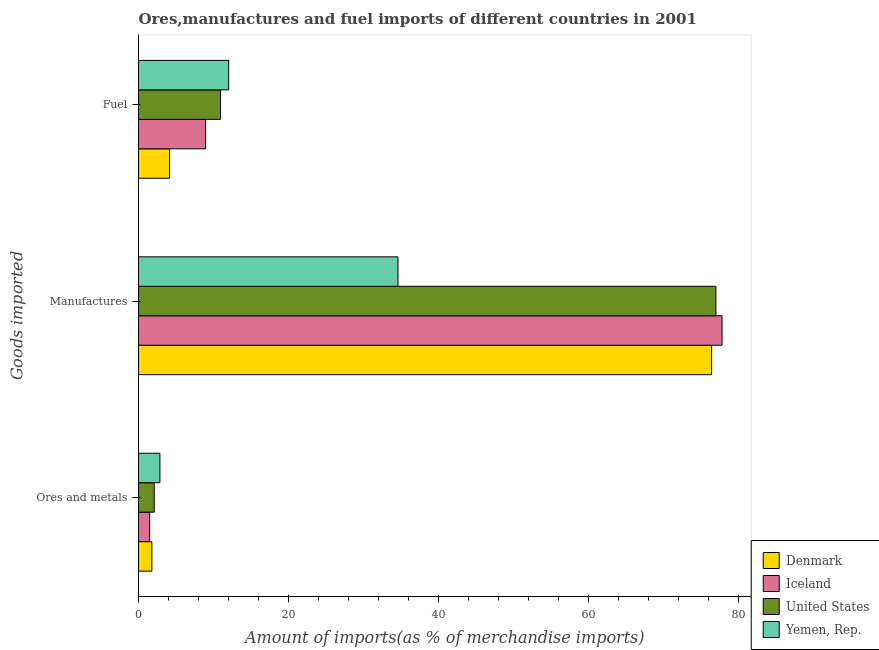How many different coloured bars are there?
Give a very brief answer. 4. How many groups of bars are there?
Your answer should be compact. 3. Are the number of bars per tick equal to the number of legend labels?
Your response must be concise. Yes. Are the number of bars on each tick of the Y-axis equal?
Make the answer very short. Yes. How many bars are there on the 2nd tick from the top?
Offer a terse response. 4. What is the label of the 2nd group of bars from the top?
Offer a terse response. Manufactures. What is the percentage of fuel imports in Denmark?
Your answer should be compact. 4.15. Across all countries, what is the maximum percentage of fuel imports?
Provide a succinct answer. 12.02. Across all countries, what is the minimum percentage of manufactures imports?
Provide a short and direct response. 34.57. In which country was the percentage of manufactures imports maximum?
Ensure brevity in your answer.  Iceland. In which country was the percentage of manufactures imports minimum?
Give a very brief answer. Yemen, Rep. What is the total percentage of ores and metals imports in the graph?
Offer a terse response. 8.21. What is the difference between the percentage of fuel imports in United States and that in Denmark?
Give a very brief answer. 6.79. What is the difference between the percentage of ores and metals imports in Denmark and the percentage of manufactures imports in Iceland?
Offer a terse response. -75.98. What is the average percentage of fuel imports per country?
Your answer should be compact. 9.01. What is the difference between the percentage of ores and metals imports and percentage of manufactures imports in United States?
Give a very brief answer. -74.85. In how many countries, is the percentage of manufactures imports greater than 28 %?
Provide a short and direct response. 4. What is the ratio of the percentage of fuel imports in Yemen, Rep. to that in United States?
Your response must be concise. 1.1. Is the percentage of fuel imports in Iceland less than that in United States?
Make the answer very short. Yes. Is the difference between the percentage of ores and metals imports in Denmark and Iceland greater than the difference between the percentage of fuel imports in Denmark and Iceland?
Your answer should be very brief. Yes. What is the difference between the highest and the second highest percentage of fuel imports?
Make the answer very short. 1.08. What is the difference between the highest and the lowest percentage of manufactures imports?
Give a very brief answer. 43.19. What does the 1st bar from the top in Ores and metals represents?
Your answer should be compact. Yemen, Rep. What does the 2nd bar from the bottom in Fuel represents?
Your response must be concise. Iceland. Are all the bars in the graph horizontal?
Give a very brief answer. Yes. How many countries are there in the graph?
Your answer should be compact. 4. What is the difference between two consecutive major ticks on the X-axis?
Provide a succinct answer. 20. Does the graph contain any zero values?
Provide a short and direct response. No. Does the graph contain grids?
Ensure brevity in your answer.  No. Where does the legend appear in the graph?
Offer a very short reply. Bottom right. How many legend labels are there?
Provide a succinct answer. 4. How are the legend labels stacked?
Ensure brevity in your answer.  Vertical. What is the title of the graph?
Your answer should be very brief. Ores,manufactures and fuel imports of different countries in 2001. What is the label or title of the X-axis?
Ensure brevity in your answer.  Amount of imports(as % of merchandise imports). What is the label or title of the Y-axis?
Your response must be concise. Goods imported. What is the Amount of imports(as % of merchandise imports) of Denmark in Ores and metals?
Make the answer very short. 1.78. What is the Amount of imports(as % of merchandise imports) in Iceland in Ores and metals?
Offer a very short reply. 1.49. What is the Amount of imports(as % of merchandise imports) of United States in Ores and metals?
Provide a succinct answer. 2.09. What is the Amount of imports(as % of merchandise imports) in Yemen, Rep. in Ores and metals?
Your response must be concise. 2.85. What is the Amount of imports(as % of merchandise imports) in Denmark in Manufactures?
Your answer should be compact. 76.38. What is the Amount of imports(as % of merchandise imports) of Iceland in Manufactures?
Your answer should be compact. 77.76. What is the Amount of imports(as % of merchandise imports) in United States in Manufactures?
Your answer should be very brief. 76.95. What is the Amount of imports(as % of merchandise imports) in Yemen, Rep. in Manufactures?
Provide a short and direct response. 34.57. What is the Amount of imports(as % of merchandise imports) of Denmark in Fuel?
Keep it short and to the point. 4.15. What is the Amount of imports(as % of merchandise imports) in Iceland in Fuel?
Give a very brief answer. 8.94. What is the Amount of imports(as % of merchandise imports) in United States in Fuel?
Make the answer very short. 10.94. What is the Amount of imports(as % of merchandise imports) of Yemen, Rep. in Fuel?
Provide a short and direct response. 12.02. Across all Goods imported, what is the maximum Amount of imports(as % of merchandise imports) in Denmark?
Offer a terse response. 76.38. Across all Goods imported, what is the maximum Amount of imports(as % of merchandise imports) in Iceland?
Make the answer very short. 77.76. Across all Goods imported, what is the maximum Amount of imports(as % of merchandise imports) of United States?
Your answer should be compact. 76.95. Across all Goods imported, what is the maximum Amount of imports(as % of merchandise imports) of Yemen, Rep.?
Your response must be concise. 34.57. Across all Goods imported, what is the minimum Amount of imports(as % of merchandise imports) in Denmark?
Offer a terse response. 1.78. Across all Goods imported, what is the minimum Amount of imports(as % of merchandise imports) in Iceland?
Keep it short and to the point. 1.49. Across all Goods imported, what is the minimum Amount of imports(as % of merchandise imports) in United States?
Your response must be concise. 2.09. Across all Goods imported, what is the minimum Amount of imports(as % of merchandise imports) of Yemen, Rep.?
Keep it short and to the point. 2.85. What is the total Amount of imports(as % of merchandise imports) in Denmark in the graph?
Make the answer very short. 82.3. What is the total Amount of imports(as % of merchandise imports) in Iceland in the graph?
Your answer should be very brief. 88.19. What is the total Amount of imports(as % of merchandise imports) of United States in the graph?
Your response must be concise. 89.98. What is the total Amount of imports(as % of merchandise imports) of Yemen, Rep. in the graph?
Keep it short and to the point. 49.44. What is the difference between the Amount of imports(as % of merchandise imports) in Denmark in Ores and metals and that in Manufactures?
Provide a succinct answer. -74.59. What is the difference between the Amount of imports(as % of merchandise imports) of Iceland in Ores and metals and that in Manufactures?
Offer a very short reply. -76.28. What is the difference between the Amount of imports(as % of merchandise imports) in United States in Ores and metals and that in Manufactures?
Offer a terse response. -74.85. What is the difference between the Amount of imports(as % of merchandise imports) of Yemen, Rep. in Ores and metals and that in Manufactures?
Ensure brevity in your answer.  -31.72. What is the difference between the Amount of imports(as % of merchandise imports) in Denmark in Ores and metals and that in Fuel?
Provide a succinct answer. -2.36. What is the difference between the Amount of imports(as % of merchandise imports) of Iceland in Ores and metals and that in Fuel?
Provide a succinct answer. -7.46. What is the difference between the Amount of imports(as % of merchandise imports) of United States in Ores and metals and that in Fuel?
Your answer should be very brief. -8.84. What is the difference between the Amount of imports(as % of merchandise imports) of Yemen, Rep. in Ores and metals and that in Fuel?
Your answer should be very brief. -9.17. What is the difference between the Amount of imports(as % of merchandise imports) of Denmark in Manufactures and that in Fuel?
Offer a terse response. 72.23. What is the difference between the Amount of imports(as % of merchandise imports) in Iceland in Manufactures and that in Fuel?
Your answer should be compact. 68.82. What is the difference between the Amount of imports(as % of merchandise imports) in United States in Manufactures and that in Fuel?
Make the answer very short. 66.01. What is the difference between the Amount of imports(as % of merchandise imports) of Yemen, Rep. in Manufactures and that in Fuel?
Your answer should be compact. 22.55. What is the difference between the Amount of imports(as % of merchandise imports) of Denmark in Ores and metals and the Amount of imports(as % of merchandise imports) of Iceland in Manufactures?
Provide a short and direct response. -75.98. What is the difference between the Amount of imports(as % of merchandise imports) in Denmark in Ores and metals and the Amount of imports(as % of merchandise imports) in United States in Manufactures?
Ensure brevity in your answer.  -75.17. What is the difference between the Amount of imports(as % of merchandise imports) of Denmark in Ores and metals and the Amount of imports(as % of merchandise imports) of Yemen, Rep. in Manufactures?
Your answer should be very brief. -32.79. What is the difference between the Amount of imports(as % of merchandise imports) in Iceland in Ores and metals and the Amount of imports(as % of merchandise imports) in United States in Manufactures?
Your answer should be very brief. -75.46. What is the difference between the Amount of imports(as % of merchandise imports) of Iceland in Ores and metals and the Amount of imports(as % of merchandise imports) of Yemen, Rep. in Manufactures?
Keep it short and to the point. -33.09. What is the difference between the Amount of imports(as % of merchandise imports) of United States in Ores and metals and the Amount of imports(as % of merchandise imports) of Yemen, Rep. in Manufactures?
Your answer should be very brief. -32.48. What is the difference between the Amount of imports(as % of merchandise imports) in Denmark in Ores and metals and the Amount of imports(as % of merchandise imports) in Iceland in Fuel?
Your response must be concise. -7.16. What is the difference between the Amount of imports(as % of merchandise imports) in Denmark in Ores and metals and the Amount of imports(as % of merchandise imports) in United States in Fuel?
Your answer should be compact. -9.16. What is the difference between the Amount of imports(as % of merchandise imports) of Denmark in Ores and metals and the Amount of imports(as % of merchandise imports) of Yemen, Rep. in Fuel?
Offer a very short reply. -10.24. What is the difference between the Amount of imports(as % of merchandise imports) of Iceland in Ores and metals and the Amount of imports(as % of merchandise imports) of United States in Fuel?
Offer a terse response. -9.45. What is the difference between the Amount of imports(as % of merchandise imports) of Iceland in Ores and metals and the Amount of imports(as % of merchandise imports) of Yemen, Rep. in Fuel?
Give a very brief answer. -10.53. What is the difference between the Amount of imports(as % of merchandise imports) in United States in Ores and metals and the Amount of imports(as % of merchandise imports) in Yemen, Rep. in Fuel?
Your answer should be compact. -9.93. What is the difference between the Amount of imports(as % of merchandise imports) in Denmark in Manufactures and the Amount of imports(as % of merchandise imports) in Iceland in Fuel?
Your answer should be compact. 67.43. What is the difference between the Amount of imports(as % of merchandise imports) in Denmark in Manufactures and the Amount of imports(as % of merchandise imports) in United States in Fuel?
Offer a very short reply. 65.44. What is the difference between the Amount of imports(as % of merchandise imports) of Denmark in Manufactures and the Amount of imports(as % of merchandise imports) of Yemen, Rep. in Fuel?
Your response must be concise. 64.36. What is the difference between the Amount of imports(as % of merchandise imports) in Iceland in Manufactures and the Amount of imports(as % of merchandise imports) in United States in Fuel?
Offer a terse response. 66.83. What is the difference between the Amount of imports(as % of merchandise imports) in Iceland in Manufactures and the Amount of imports(as % of merchandise imports) in Yemen, Rep. in Fuel?
Keep it short and to the point. 65.74. What is the difference between the Amount of imports(as % of merchandise imports) of United States in Manufactures and the Amount of imports(as % of merchandise imports) of Yemen, Rep. in Fuel?
Give a very brief answer. 64.93. What is the average Amount of imports(as % of merchandise imports) of Denmark per Goods imported?
Give a very brief answer. 27.43. What is the average Amount of imports(as % of merchandise imports) in Iceland per Goods imported?
Keep it short and to the point. 29.4. What is the average Amount of imports(as % of merchandise imports) of United States per Goods imported?
Offer a very short reply. 29.99. What is the average Amount of imports(as % of merchandise imports) in Yemen, Rep. per Goods imported?
Give a very brief answer. 16.48. What is the difference between the Amount of imports(as % of merchandise imports) in Denmark and Amount of imports(as % of merchandise imports) in Iceland in Ores and metals?
Your answer should be compact. 0.29. What is the difference between the Amount of imports(as % of merchandise imports) in Denmark and Amount of imports(as % of merchandise imports) in United States in Ores and metals?
Ensure brevity in your answer.  -0.31. What is the difference between the Amount of imports(as % of merchandise imports) of Denmark and Amount of imports(as % of merchandise imports) of Yemen, Rep. in Ores and metals?
Keep it short and to the point. -1.07. What is the difference between the Amount of imports(as % of merchandise imports) in Iceland and Amount of imports(as % of merchandise imports) in United States in Ores and metals?
Ensure brevity in your answer.  -0.61. What is the difference between the Amount of imports(as % of merchandise imports) in Iceland and Amount of imports(as % of merchandise imports) in Yemen, Rep. in Ores and metals?
Offer a very short reply. -1.37. What is the difference between the Amount of imports(as % of merchandise imports) of United States and Amount of imports(as % of merchandise imports) of Yemen, Rep. in Ores and metals?
Your answer should be very brief. -0.76. What is the difference between the Amount of imports(as % of merchandise imports) in Denmark and Amount of imports(as % of merchandise imports) in Iceland in Manufactures?
Give a very brief answer. -1.39. What is the difference between the Amount of imports(as % of merchandise imports) in Denmark and Amount of imports(as % of merchandise imports) in United States in Manufactures?
Offer a very short reply. -0.57. What is the difference between the Amount of imports(as % of merchandise imports) in Denmark and Amount of imports(as % of merchandise imports) in Yemen, Rep. in Manufactures?
Your response must be concise. 41.8. What is the difference between the Amount of imports(as % of merchandise imports) in Iceland and Amount of imports(as % of merchandise imports) in United States in Manufactures?
Keep it short and to the point. 0.82. What is the difference between the Amount of imports(as % of merchandise imports) of Iceland and Amount of imports(as % of merchandise imports) of Yemen, Rep. in Manufactures?
Offer a very short reply. 43.19. What is the difference between the Amount of imports(as % of merchandise imports) in United States and Amount of imports(as % of merchandise imports) in Yemen, Rep. in Manufactures?
Make the answer very short. 42.38. What is the difference between the Amount of imports(as % of merchandise imports) in Denmark and Amount of imports(as % of merchandise imports) in Iceland in Fuel?
Your response must be concise. -4.8. What is the difference between the Amount of imports(as % of merchandise imports) in Denmark and Amount of imports(as % of merchandise imports) in United States in Fuel?
Ensure brevity in your answer.  -6.79. What is the difference between the Amount of imports(as % of merchandise imports) in Denmark and Amount of imports(as % of merchandise imports) in Yemen, Rep. in Fuel?
Provide a succinct answer. -7.87. What is the difference between the Amount of imports(as % of merchandise imports) in Iceland and Amount of imports(as % of merchandise imports) in United States in Fuel?
Your answer should be compact. -1.99. What is the difference between the Amount of imports(as % of merchandise imports) in Iceland and Amount of imports(as % of merchandise imports) in Yemen, Rep. in Fuel?
Your response must be concise. -3.08. What is the difference between the Amount of imports(as % of merchandise imports) in United States and Amount of imports(as % of merchandise imports) in Yemen, Rep. in Fuel?
Your answer should be compact. -1.08. What is the ratio of the Amount of imports(as % of merchandise imports) of Denmark in Ores and metals to that in Manufactures?
Make the answer very short. 0.02. What is the ratio of the Amount of imports(as % of merchandise imports) of Iceland in Ores and metals to that in Manufactures?
Make the answer very short. 0.02. What is the ratio of the Amount of imports(as % of merchandise imports) in United States in Ores and metals to that in Manufactures?
Make the answer very short. 0.03. What is the ratio of the Amount of imports(as % of merchandise imports) of Yemen, Rep. in Ores and metals to that in Manufactures?
Make the answer very short. 0.08. What is the ratio of the Amount of imports(as % of merchandise imports) of Denmark in Ores and metals to that in Fuel?
Your response must be concise. 0.43. What is the ratio of the Amount of imports(as % of merchandise imports) in Iceland in Ores and metals to that in Fuel?
Give a very brief answer. 0.17. What is the ratio of the Amount of imports(as % of merchandise imports) in United States in Ores and metals to that in Fuel?
Your response must be concise. 0.19. What is the ratio of the Amount of imports(as % of merchandise imports) in Yemen, Rep. in Ores and metals to that in Fuel?
Offer a very short reply. 0.24. What is the ratio of the Amount of imports(as % of merchandise imports) of Denmark in Manufactures to that in Fuel?
Keep it short and to the point. 18.43. What is the ratio of the Amount of imports(as % of merchandise imports) in Iceland in Manufactures to that in Fuel?
Your answer should be very brief. 8.7. What is the ratio of the Amount of imports(as % of merchandise imports) of United States in Manufactures to that in Fuel?
Offer a terse response. 7.04. What is the ratio of the Amount of imports(as % of merchandise imports) of Yemen, Rep. in Manufactures to that in Fuel?
Provide a short and direct response. 2.88. What is the difference between the highest and the second highest Amount of imports(as % of merchandise imports) in Denmark?
Provide a short and direct response. 72.23. What is the difference between the highest and the second highest Amount of imports(as % of merchandise imports) of Iceland?
Keep it short and to the point. 68.82. What is the difference between the highest and the second highest Amount of imports(as % of merchandise imports) of United States?
Make the answer very short. 66.01. What is the difference between the highest and the second highest Amount of imports(as % of merchandise imports) in Yemen, Rep.?
Keep it short and to the point. 22.55. What is the difference between the highest and the lowest Amount of imports(as % of merchandise imports) of Denmark?
Offer a terse response. 74.59. What is the difference between the highest and the lowest Amount of imports(as % of merchandise imports) in Iceland?
Ensure brevity in your answer.  76.28. What is the difference between the highest and the lowest Amount of imports(as % of merchandise imports) of United States?
Offer a terse response. 74.85. What is the difference between the highest and the lowest Amount of imports(as % of merchandise imports) in Yemen, Rep.?
Your response must be concise. 31.72. 